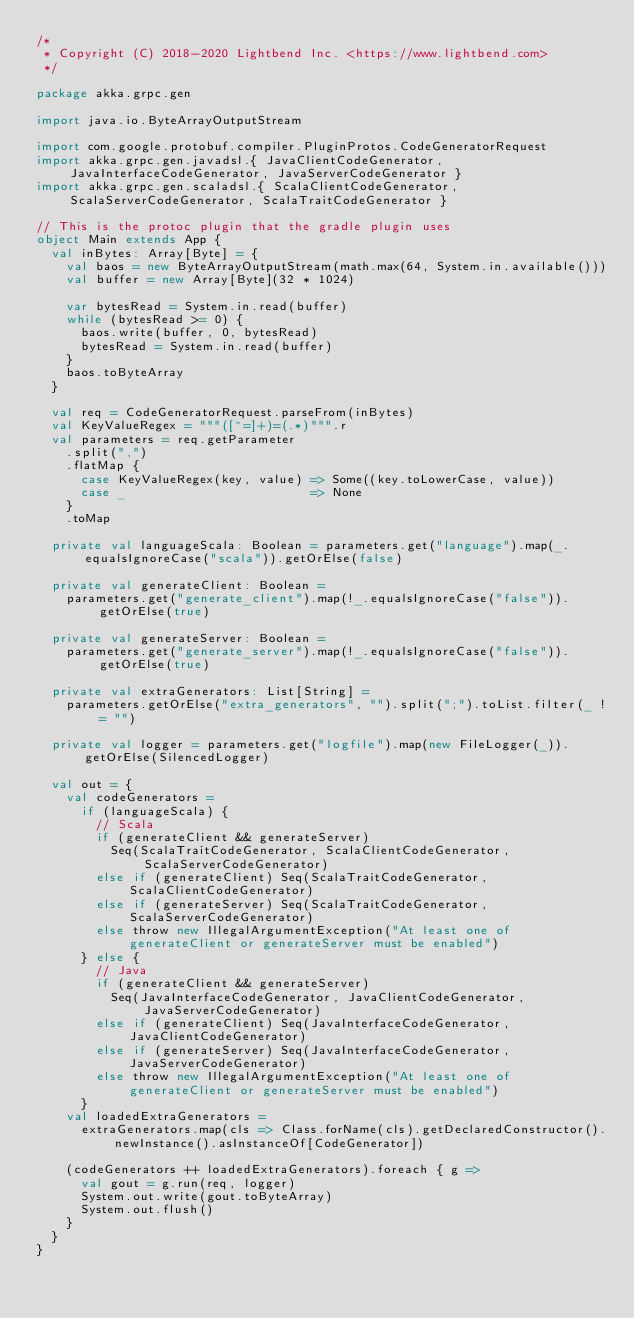<code> <loc_0><loc_0><loc_500><loc_500><_Scala_>/*
 * Copyright (C) 2018-2020 Lightbend Inc. <https://www.lightbend.com>
 */

package akka.grpc.gen

import java.io.ByteArrayOutputStream

import com.google.protobuf.compiler.PluginProtos.CodeGeneratorRequest
import akka.grpc.gen.javadsl.{ JavaClientCodeGenerator, JavaInterfaceCodeGenerator, JavaServerCodeGenerator }
import akka.grpc.gen.scaladsl.{ ScalaClientCodeGenerator, ScalaServerCodeGenerator, ScalaTraitCodeGenerator }

// This is the protoc plugin that the gradle plugin uses
object Main extends App {
  val inBytes: Array[Byte] = {
    val baos = new ByteArrayOutputStream(math.max(64, System.in.available()))
    val buffer = new Array[Byte](32 * 1024)

    var bytesRead = System.in.read(buffer)
    while (bytesRead >= 0) {
      baos.write(buffer, 0, bytesRead)
      bytesRead = System.in.read(buffer)
    }
    baos.toByteArray
  }

  val req = CodeGeneratorRequest.parseFrom(inBytes)
  val KeyValueRegex = """([^=]+)=(.*)""".r
  val parameters = req.getParameter
    .split(",")
    .flatMap {
      case KeyValueRegex(key, value) => Some((key.toLowerCase, value))
      case _                         => None
    }
    .toMap

  private val languageScala: Boolean = parameters.get("language").map(_.equalsIgnoreCase("scala")).getOrElse(false)

  private val generateClient: Boolean =
    parameters.get("generate_client").map(!_.equalsIgnoreCase("false")).getOrElse(true)

  private val generateServer: Boolean =
    parameters.get("generate_server").map(!_.equalsIgnoreCase("false")).getOrElse(true)

  private val extraGenerators: List[String] =
    parameters.getOrElse("extra_generators", "").split(";").toList.filter(_ != "")

  private val logger = parameters.get("logfile").map(new FileLogger(_)).getOrElse(SilencedLogger)

  val out = {
    val codeGenerators =
      if (languageScala) {
        // Scala
        if (generateClient && generateServer)
          Seq(ScalaTraitCodeGenerator, ScalaClientCodeGenerator, ScalaServerCodeGenerator)
        else if (generateClient) Seq(ScalaTraitCodeGenerator, ScalaClientCodeGenerator)
        else if (generateServer) Seq(ScalaTraitCodeGenerator, ScalaServerCodeGenerator)
        else throw new IllegalArgumentException("At least one of generateClient or generateServer must be enabled")
      } else {
        // Java
        if (generateClient && generateServer)
          Seq(JavaInterfaceCodeGenerator, JavaClientCodeGenerator, JavaServerCodeGenerator)
        else if (generateClient) Seq(JavaInterfaceCodeGenerator, JavaClientCodeGenerator)
        else if (generateServer) Seq(JavaInterfaceCodeGenerator, JavaServerCodeGenerator)
        else throw new IllegalArgumentException("At least one of generateClient or generateServer must be enabled")
      }
    val loadedExtraGenerators =
      extraGenerators.map(cls => Class.forName(cls).getDeclaredConstructor().newInstance().asInstanceOf[CodeGenerator])

    (codeGenerators ++ loadedExtraGenerators).foreach { g =>
      val gout = g.run(req, logger)
      System.out.write(gout.toByteArray)
      System.out.flush()
    }
  }
}
</code> 